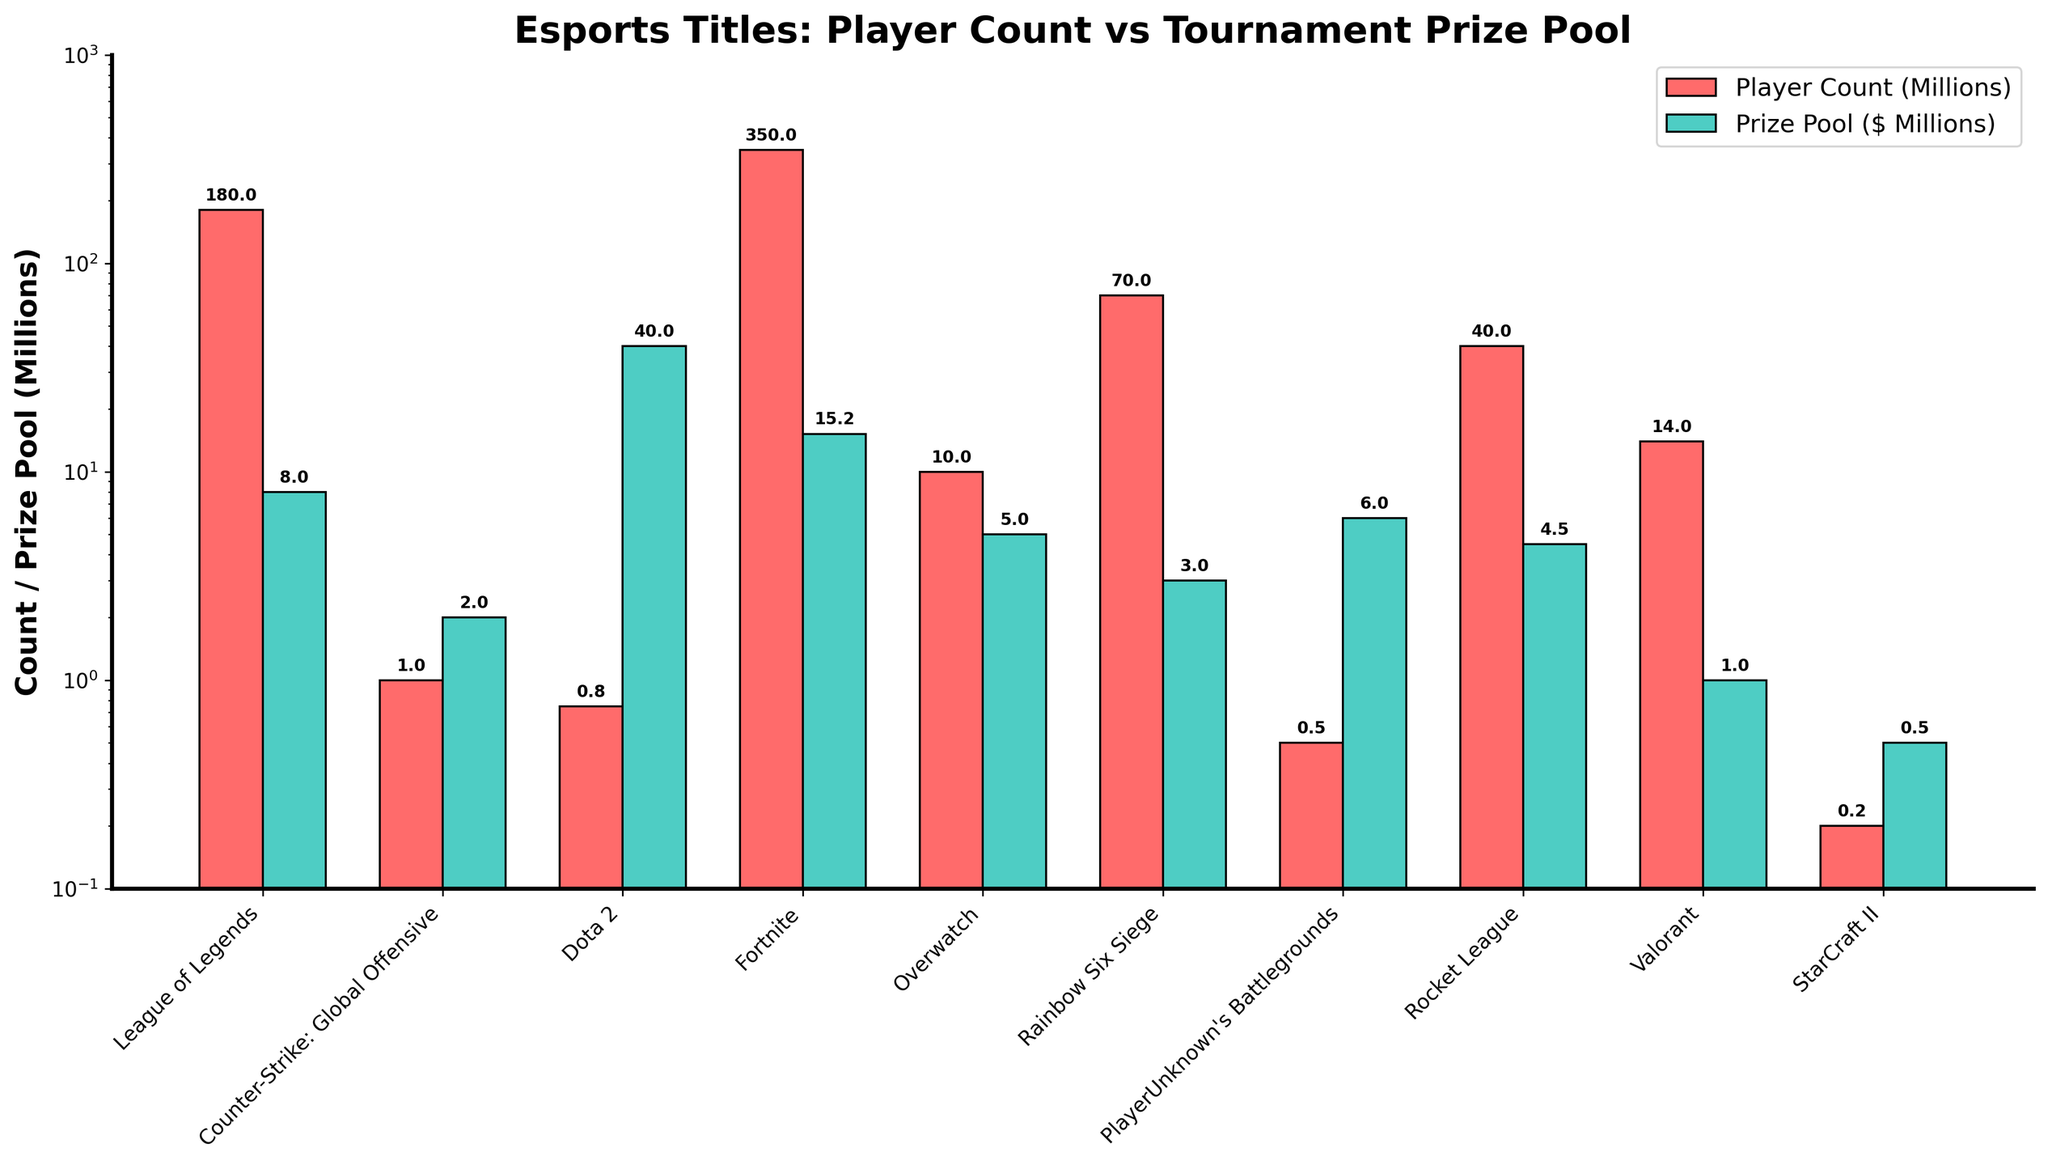Which game has the highest player count? Look at the height of the red bars, which represent player count. The tallest bar corresponds to Fortnite.
Answer: Fortnite Which game has the largest tournament prize pool? Look at the height of the teal bars, which represent the tournament prize pool. The tallest bar corresponds to Dota 2.
Answer: Dota 2 Which game has the smallest player count? Look at the height of the red bars and identify the shortest one. The shortest bar corresponds to StarCraft II.
Answer: StarCraft II What is the difference in player count between Counter-Strike: Global Offensive and Valorant? Look at the height of the red bars for both Counter-Strike: Global Offensive (1 million) and Valorant (14 million), and subtract the smaller value from the larger one.
Answer: 13 million How many games have player counts exceeding 100 million? Count the number of red bars that are taller than the height corresponding to 100 million. Both Fortnite and League of Legends exceed this threshold.
Answer: 2 Which game has a higher prize pool: Overwatch or Rainbow Six Siege? Compare the heights of the teal bars for Overwatch and Rainbow Six Siege. Overwatch has a higher prize pool.
Answer: Overwatch What is the total prize pool for the top three games with the largest prize pools? Identify the three tallest teal bars: Dota 2, Fortnite, and League of Legends. Sum their corresponding prize pool values: 40.018195 + 15.2 + 7.97 million.
Answer: 63.188195 million Which game has a higher player count: Rocket League or Overwatch? Compare the heights of the red bars for Rocket League and Overwatch. Rocket League has a higher player count.
Answer: Rocket League What is the ratio of the prize pool of League of Legends to that of Valorant? Divide the prize pool value of League of Legends (7.97 million) by the prize pool value of Valorant (1 million).
Answer: 7.97 Which game has a higher player count: StarCraft II or PlayerUnknown's Battlegrounds? Compare the heights of the red bars for StarCraft II and PlayerUnknown's Battlegrounds. PlayerUnknown's Battlegrounds has a higher player count.
Answer: PlayerUnknown's Battlegrounds 